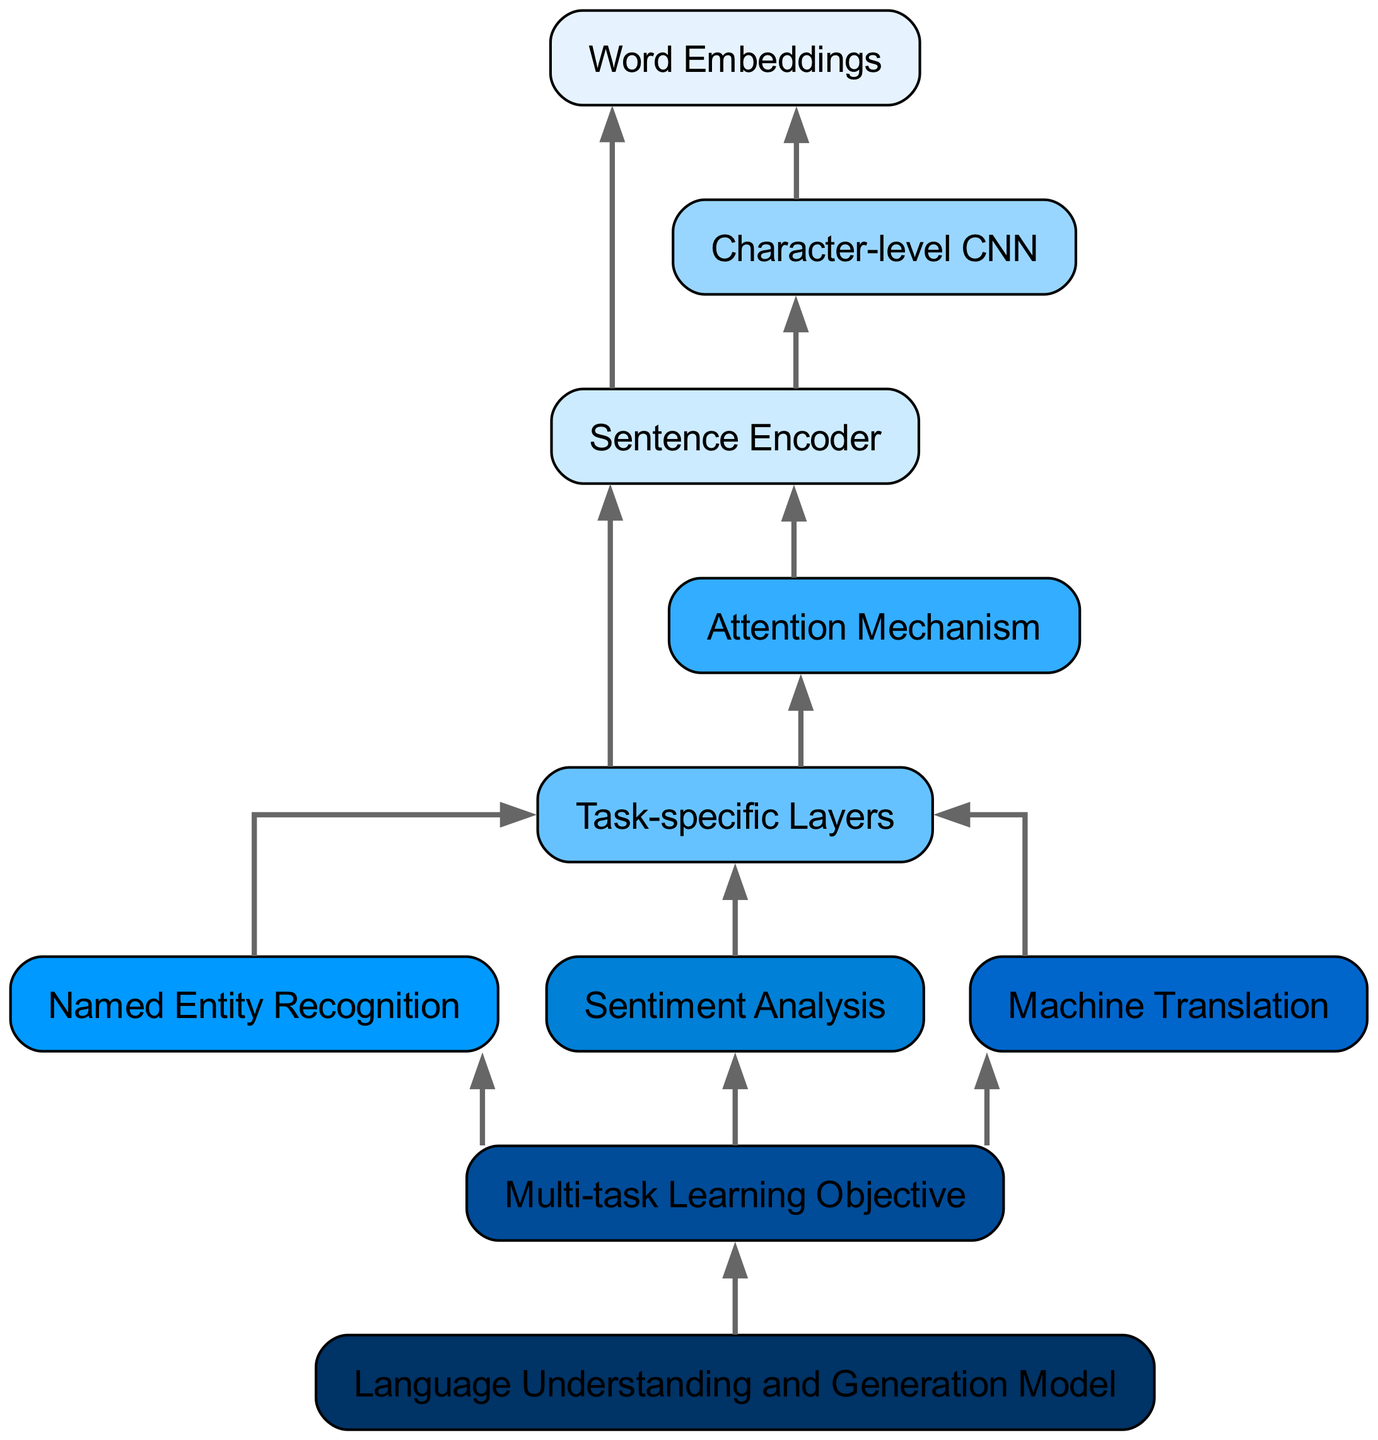What is the top-level node in the diagram? The top-level node in the diagram is the "Word Embeddings" which is the first element listed. It is the starting point of the flowchart and has two children nodes.
Answer: Word Embeddings How many children nodes does "Sentence Encoder" have? "Sentence Encoder" has two children nodes, which are "Task-specific Layers" and "Attention Mechanism". This can be confirmed by reviewing the connections in the diagram.
Answer: 2 What task is associated with "Attention Mechanism"? "Attention Mechanism" is associated with "Task-specific Layers" according to the diagram. This is shown by the direct link from "Attention Mechanism" to "Task-specific Layers".
Answer: Task-specific Layers Which component is a child of "Multi-task Learning Objective"? The direct child of "Multi-task Learning Objective" is the "Language Understanding and Generation Model". This is represented by a single arrow leading to it from the "Multi-task Learning Objective".
Answer: Language Understanding and Generation Model What is the total number of task-specific layers depicted in the diagram? The diagram shows three distinct task-specific layers: "Named Entity Recognition", "Sentiment Analysis", and "Machine Translation". Each layer serves a different task and has its own node.
Answer: 3 Which node is directly linked to both "Character-level CNN" and "Sentence Encoder"? "Sentence Encoder" is directly linked to "Character-level CNN", signifying that "Character-level CNN" serves as a foundational part of "Sentence Encoder". This is established by tracing the paths leading from "Character-level CNN".
Answer: Sentence Encoder What is the connection between "Named Entity Recognition", "Sentiment Analysis", and "Multi-task Learning Objective"? "Named Entity Recognition" and "Sentiment Analysis" are both connected to the "Multi-task Learning Objective" through the "Task-specific Layers". This indicates that these tasks contribute to a shared objective within the framework.
Answer: Multi-task Learning Objective How is the "Attention Mechanism" related to the overall task structure depicted in the diagram? "Attention Mechanism" feeds directly into "Task-specific Layers", indicating its role in enhancing the performance of these layers on various tasks under the multi-task learning framework.
Answer: Task-specific Layers 